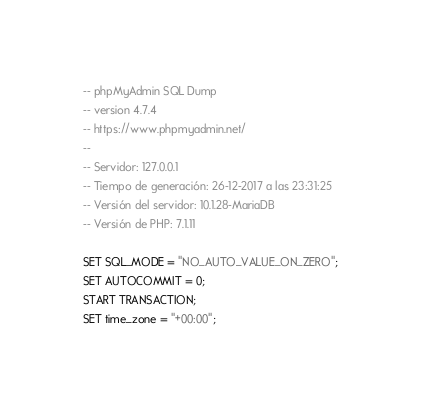<code> <loc_0><loc_0><loc_500><loc_500><_SQL_>-- phpMyAdmin SQL Dump
-- version 4.7.4
-- https://www.phpmyadmin.net/
--
-- Servidor: 127.0.0.1
-- Tiempo de generación: 26-12-2017 a las 23:31:25
-- Versión del servidor: 10.1.28-MariaDB
-- Versión de PHP: 7.1.11

SET SQL_MODE = "NO_AUTO_VALUE_ON_ZERO";
SET AUTOCOMMIT = 0;
START TRANSACTION;
SET time_zone = "+00:00";

</code> 